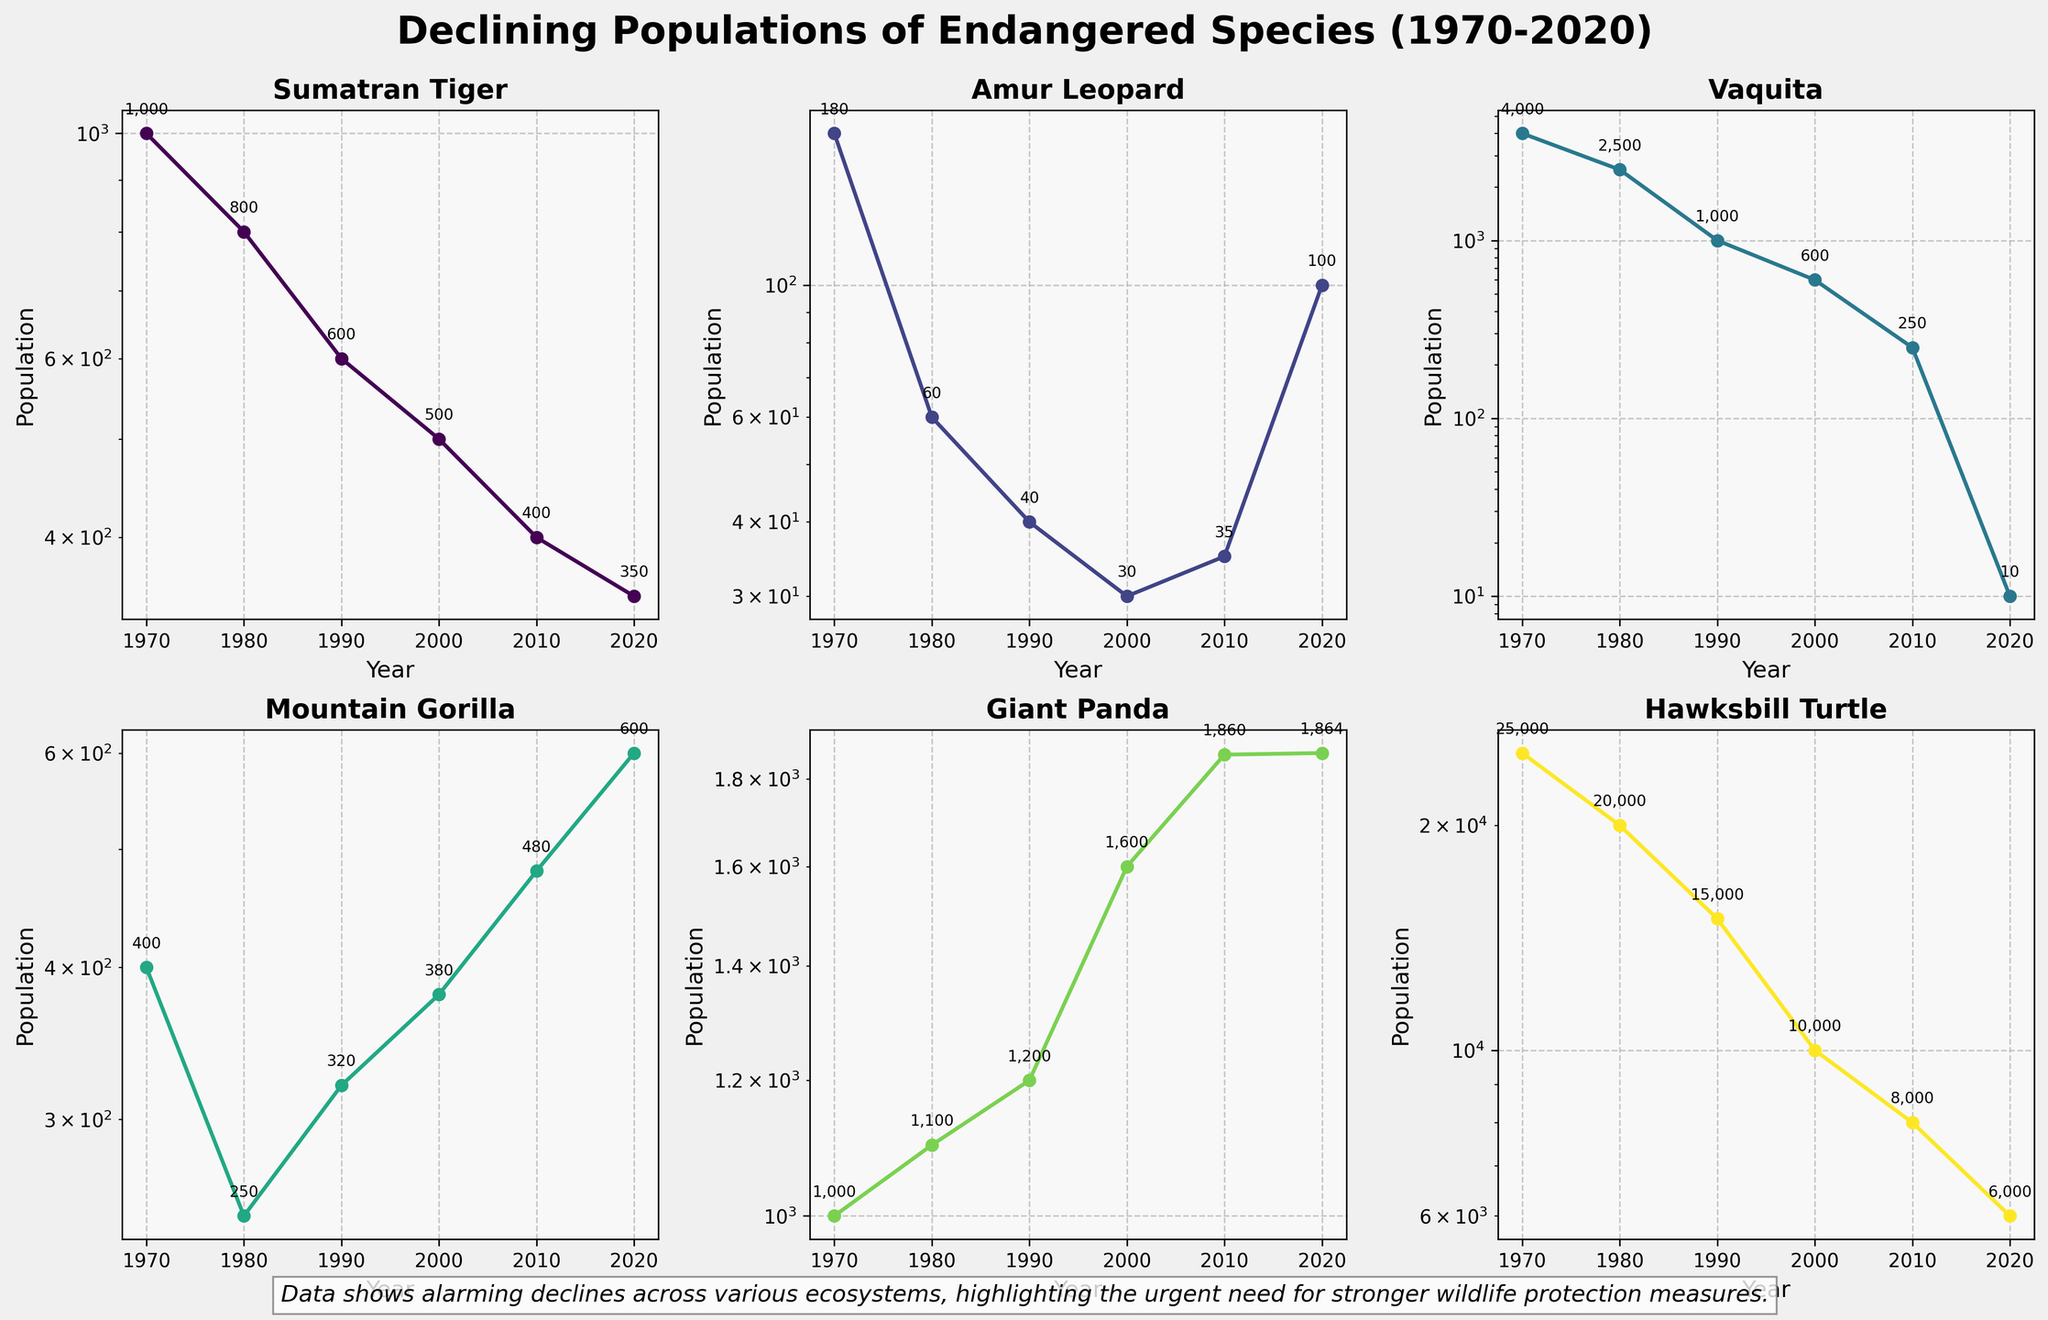How many species are represented in the figure? To determine the number of species, count the titles of each subplot which represent different species. There are subplots for Sumatran Tiger, Amur Leopard, Vaquita, Mountain Gorilla, Giant Panda, and Hawksbill Turtle.
Answer: 6 What is the population trend of the Vaquita from 1970 to 2020? The population of the Vaquita shows a steady decline over the years. Start by looking at each year's data point for the Vaquita and note the decline from 4000 in 1970 to 10 in 2020.
Answer: Declining Which species had the highest population in 2020? Compare the population values for each species in the year 2020. The Hawksbill Turtle had a population of 6000, which is higher than all the other species.
Answer: Hawksbill Turtle What was the approximate population of the Mountain Gorilla in 1990? Locate the data point for Mountain Gorilla in the subplot for 1990. The value is 320.
Answer: 320 Between which years did the Amur Leopard see the largest decline in population? Look at the Amur Leopard subplot and observe the changes between data points. The largest decline occurs between 1970 and 1980 (from 180 to 60).
Answer: 1970 to 1980 Comparing the trends, which species show any signs of population increase in recent years? Examine the recent data points (2010 to 2020) for each species. The Giant Panda and Mountain Gorilla populations show slight increases during this period.
Answer: Giant Panda and Mountain Gorilla What was the population of the Sumatran Tiger in 1980 and how does it compare to 1970? Find the population values for the Sumatran Tiger in 1980 (800) and compare it to 1970 (1000).
Answer: Decreased by 200 For which species is the y-axis set to log scale most useful? Identify species with wide population ranges by examining the y-axes. Species with large differences in their population values, such as Hawksbill Turtle (25000 to 6000) and Vaquita (4000 to 10), benefit most from a log scale.
Answer: Hawksbill Turtle and Vaquita 